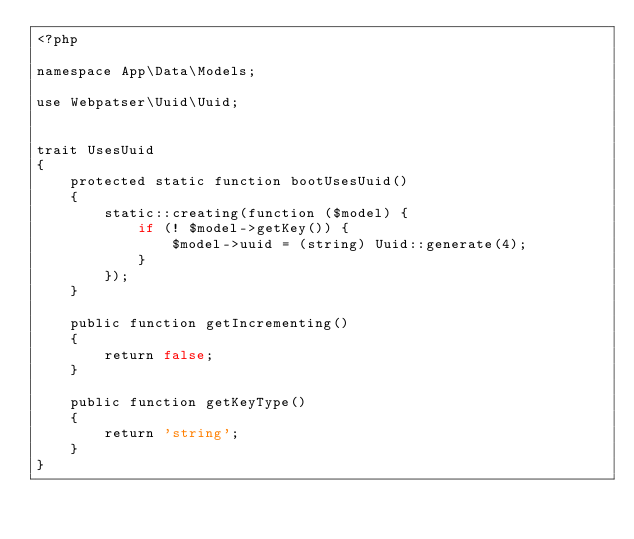Convert code to text. <code><loc_0><loc_0><loc_500><loc_500><_PHP_><?php

namespace App\Data\Models;

use Webpatser\Uuid\Uuid;


trait UsesUuid
{
    protected static function bootUsesUuid()
    {
        static::creating(function ($model) {
            if (! $model->getKey()) {
                $model->uuid = (string) Uuid::generate(4);
            }
        });
    }

    public function getIncrementing()
    {
        return false;
    }

    public function getKeyType()
    {
        return 'string';
    }
}
</code> 